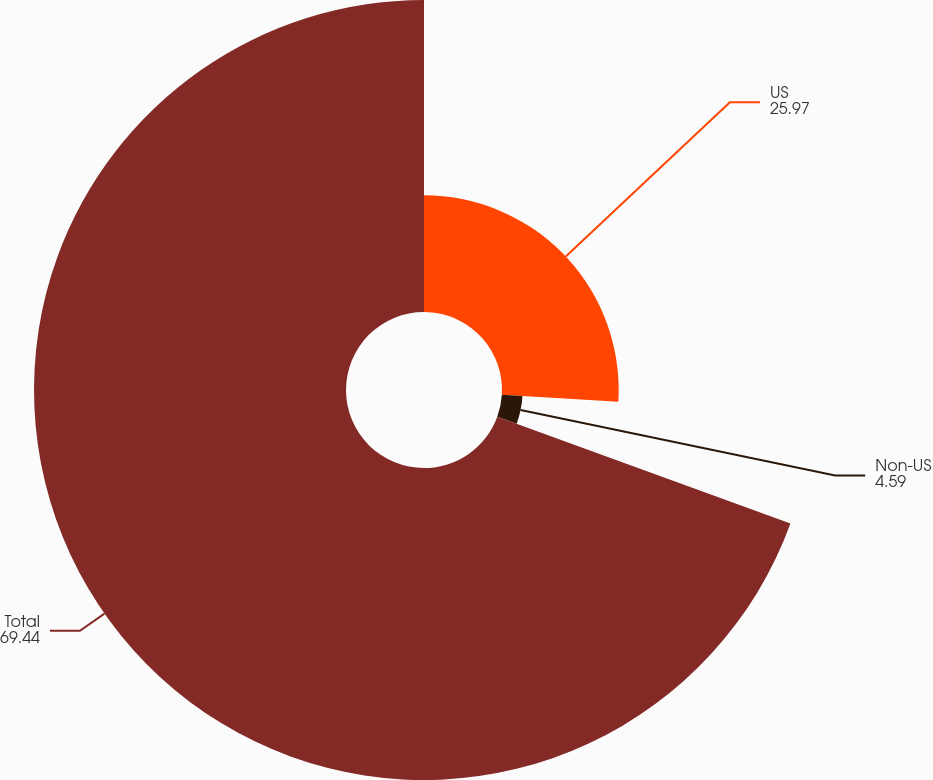<chart> <loc_0><loc_0><loc_500><loc_500><pie_chart><fcel>US<fcel>Non-US<fcel>Total<nl><fcel>25.97%<fcel>4.59%<fcel>69.44%<nl></chart> 